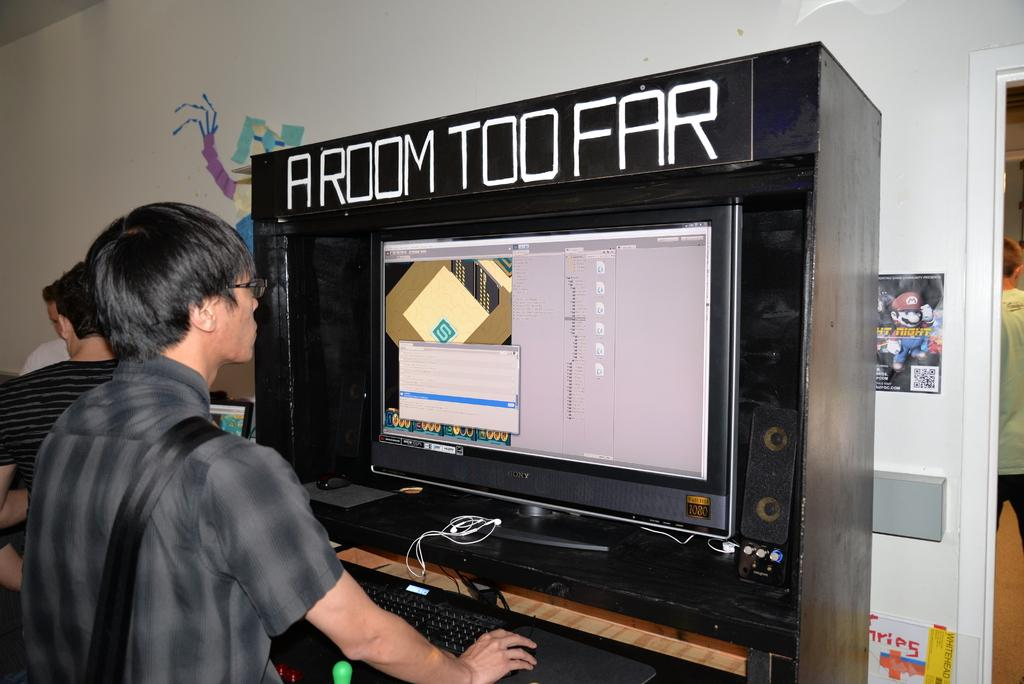<image>
Present a compact description of the photo's key features. A display on a large monitor housed inside astrange looking box labeled "a room too far" is examined by a young adult 